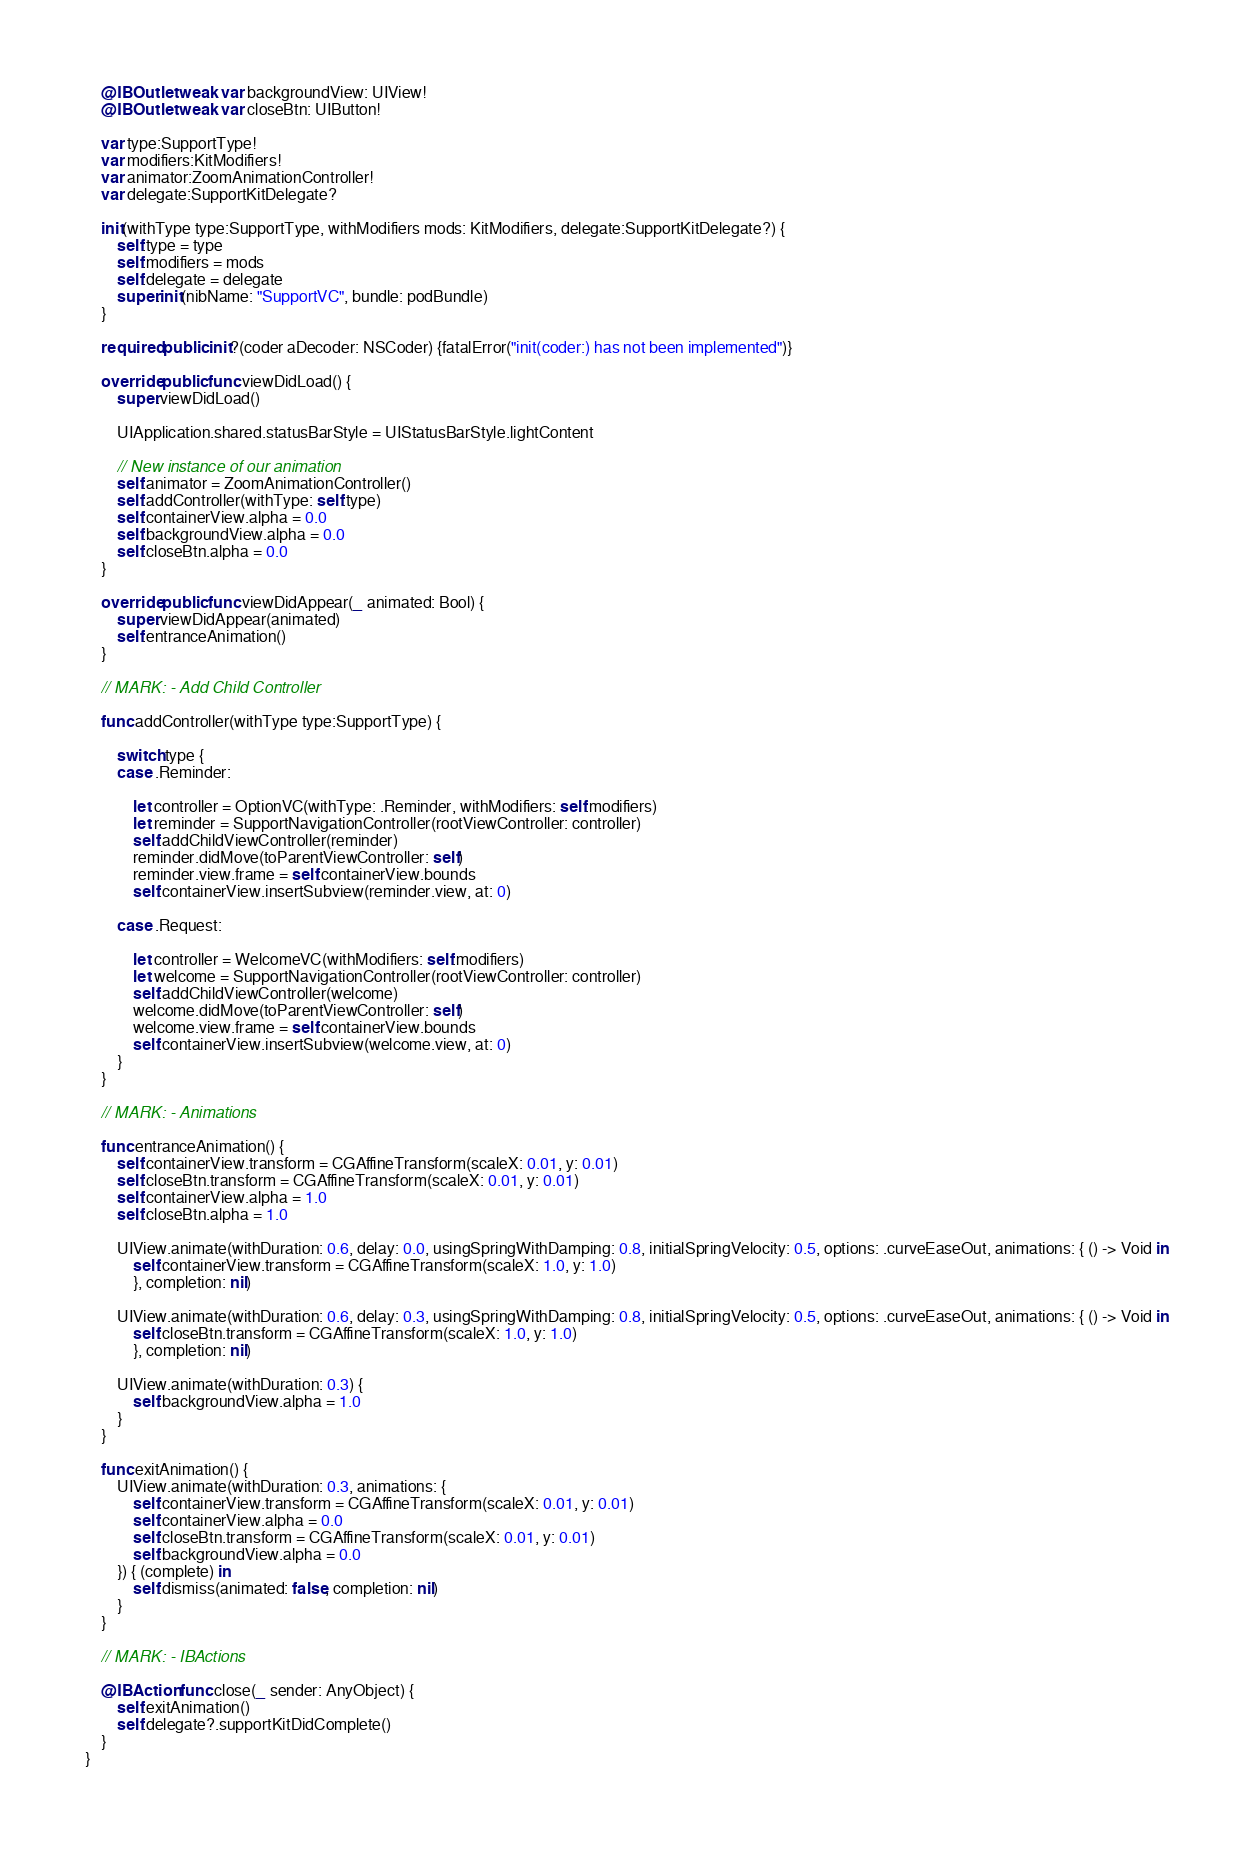<code> <loc_0><loc_0><loc_500><loc_500><_Swift_>    @IBOutlet weak var backgroundView: UIView!
    @IBOutlet weak var closeBtn: UIButton!
    
    var type:SupportType!
    var modifiers:KitModifiers!
    var animator:ZoomAnimationController!
    var delegate:SupportKitDelegate?
    
    init(withType type:SupportType, withModifiers mods: KitModifiers, delegate:SupportKitDelegate?) {
        self.type = type
        self.modifiers = mods
        self.delegate = delegate
        super.init(nibName: "SupportVC", bundle: podBundle)
    }
    
    required public init?(coder aDecoder: NSCoder) {fatalError("init(coder:) has not been implemented")}

    override public func viewDidLoad() {
        super.viewDidLoad()
        
        UIApplication.shared.statusBarStyle = UIStatusBarStyle.lightContent
        
        // New instance of our animation
        self.animator = ZoomAnimationController()
        self.addController(withType: self.type)
        self.containerView.alpha = 0.0
        self.backgroundView.alpha = 0.0
        self.closeBtn.alpha = 0.0
    }
    
    override public func viewDidAppear(_ animated: Bool) {
        super.viewDidAppear(animated)
        self.entranceAnimation()
    }
    
    // MARK: - Add Child Controller
    
    func addController(withType type:SupportType) {
        
        switch type {
        case .Reminder:
            
            let controller = OptionVC(withType: .Reminder, withModifiers: self.modifiers)
            let reminder = SupportNavigationController(rootViewController: controller)
            self.addChildViewController(reminder)
            reminder.didMove(toParentViewController: self)
            reminder.view.frame = self.containerView.bounds
            self.containerView.insertSubview(reminder.view, at: 0)
            
        case .Request:
            
            let controller = WelcomeVC(withModifiers: self.modifiers)
            let welcome = SupportNavigationController(rootViewController: controller)
            self.addChildViewController(welcome)
            welcome.didMove(toParentViewController: self)
            welcome.view.frame = self.containerView.bounds
            self.containerView.insertSubview(welcome.view, at: 0)
        }
    }
    
    // MARK: - Animations
    
    func entranceAnimation() {
        self.containerView.transform = CGAffineTransform(scaleX: 0.01, y: 0.01)
        self.closeBtn.transform = CGAffineTransform(scaleX: 0.01, y: 0.01)
        self.containerView.alpha = 1.0
        self.closeBtn.alpha = 1.0
        
        UIView.animate(withDuration: 0.6, delay: 0.0, usingSpringWithDamping: 0.8, initialSpringVelocity: 0.5, options: .curveEaseOut, animations: { () -> Void in
            self.containerView.transform = CGAffineTransform(scaleX: 1.0, y: 1.0)
            }, completion: nil)
        
        UIView.animate(withDuration: 0.6, delay: 0.3, usingSpringWithDamping: 0.8, initialSpringVelocity: 0.5, options: .curveEaseOut, animations: { () -> Void in
            self.closeBtn.transform = CGAffineTransform(scaleX: 1.0, y: 1.0)
            }, completion: nil)
        
        UIView.animate(withDuration: 0.3) {
            self.backgroundView.alpha = 1.0
        }
    }
    
    func exitAnimation() {
        UIView.animate(withDuration: 0.3, animations: {
            self.containerView.transform = CGAffineTransform(scaleX: 0.01, y: 0.01)
            self.containerView.alpha = 0.0
            self.closeBtn.transform = CGAffineTransform(scaleX: 0.01, y: 0.01)
            self.backgroundView.alpha = 0.0
        }) { (complete) in
            self.dismiss(animated: false, completion: nil)
        }
    }
    
    // MARK: - IBActions
    
    @IBAction func close(_ sender: AnyObject) {
        self.exitAnimation()
        self.delegate?.supportKitDidComplete()
    }
}

</code> 